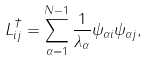<formula> <loc_0><loc_0><loc_500><loc_500>L ^ { \dagger } _ { i j } = \sum _ { \alpha = 1 } ^ { N - 1 } \frac { 1 } { \lambda _ { \alpha } } \psi _ { \alpha i } \psi _ { \alpha j } ,</formula> 